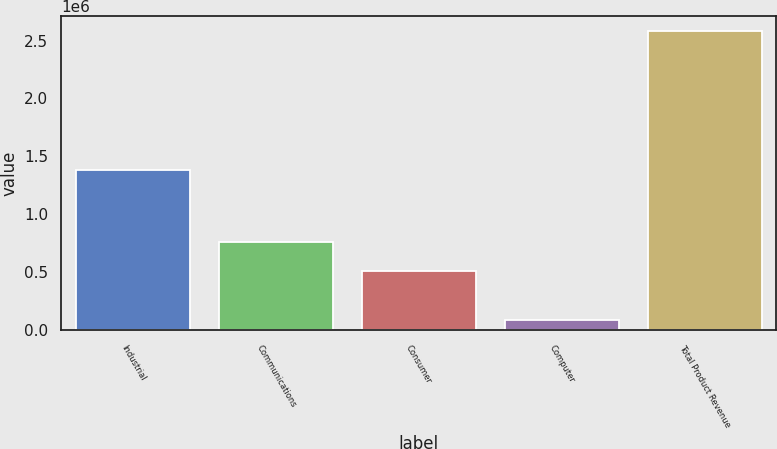<chart> <loc_0><loc_0><loc_500><loc_500><bar_chart><fcel>Industrial<fcel>Communications<fcel>Consumer<fcel>Computer<fcel>Total Product Revenue<nl><fcel>1.38687e+06<fcel>761287<fcel>512339<fcel>93451<fcel>2.58293e+06<nl></chart> 